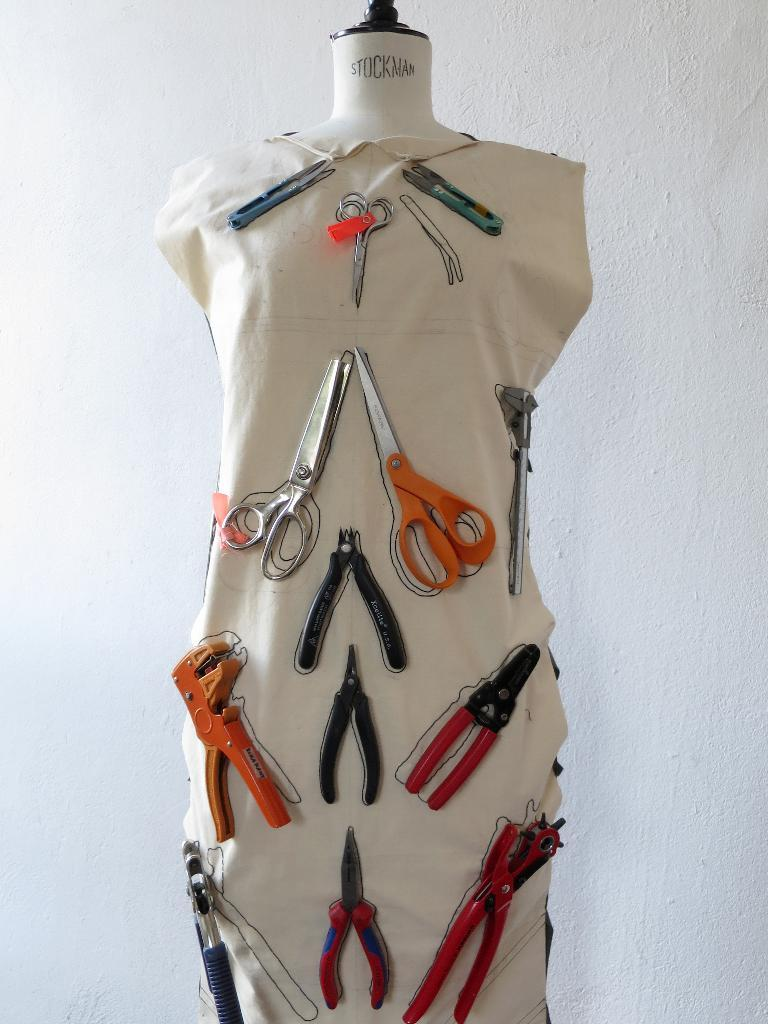What is the main subject in the image? There is a mannequin in the image. What is placed on the mannequin? The mannequin has a cloth on it. What tools can be seen on the cloth? There are scissors, pliers, and other tools on the cloth. What is visible in the background of the image? There is a wall in the background of the image. How many cars are parked next to the mannequin in the image? There are no cars present in the image; it only features a mannequin with a cloth and tools on it, along with a wall in the background. 